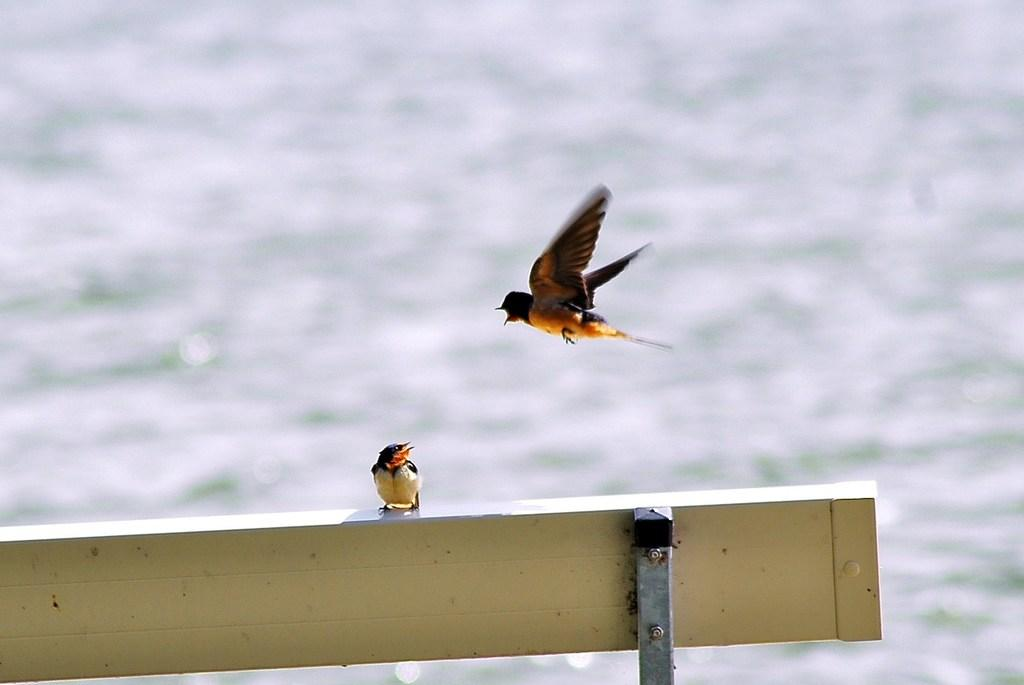What is sitting on the bench in the image? There is a bird on the bench in the image. Can you describe the other bird in the image? There is another bird in the air in the image. What can be seen in the background of the image? There is water visible in the background of the image. What type of yam is being used as a representative in the image? There is no yam present in the image, and therefore no such representation can be observed. 